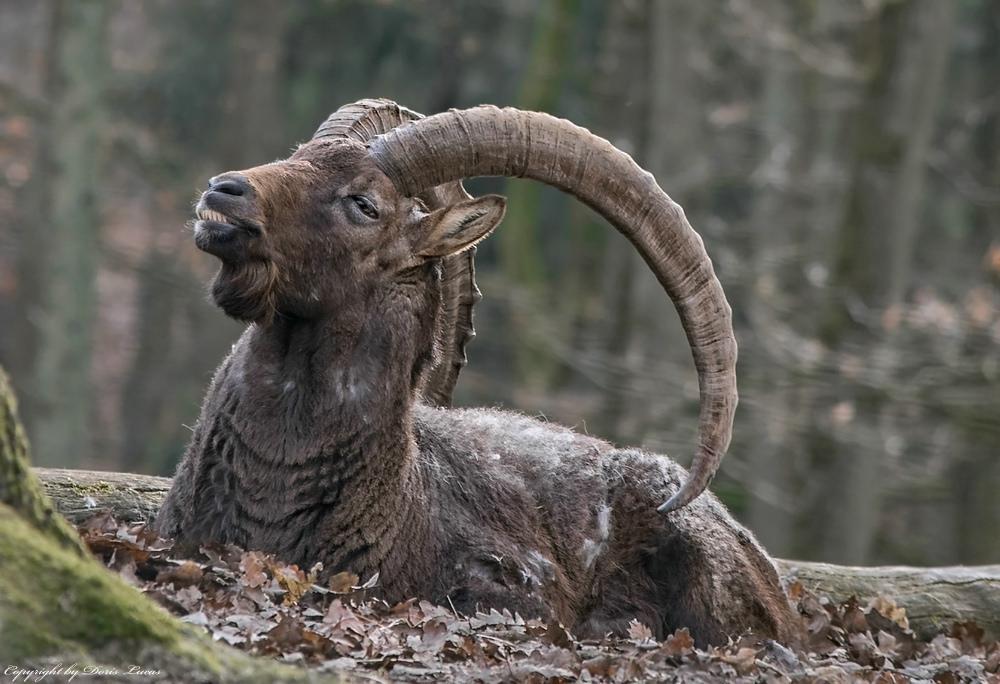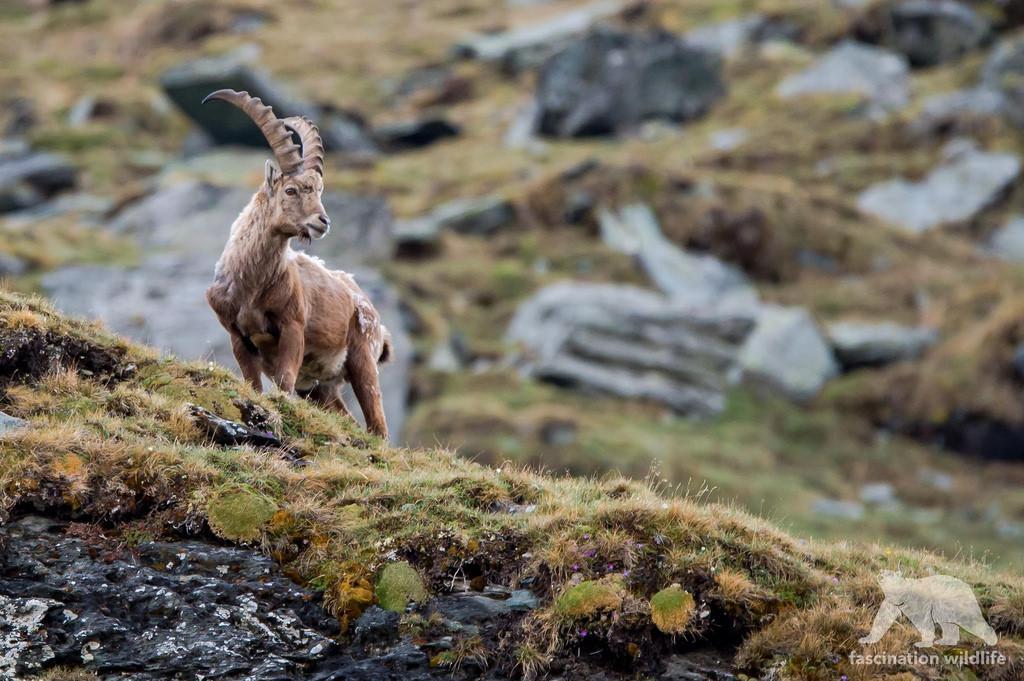The first image is the image on the left, the second image is the image on the right. Evaluate the accuracy of this statement regarding the images: "One of the goats is on the ground, resting.". Is it true? Answer yes or no. Yes. 